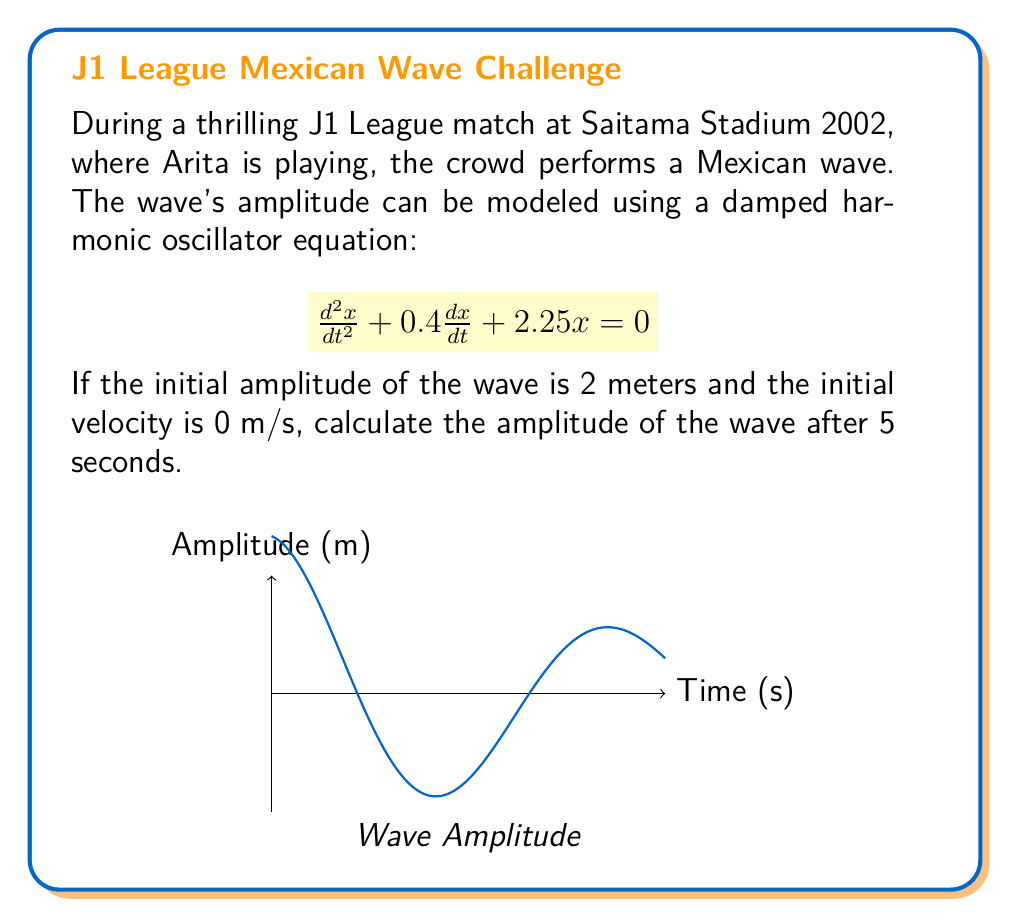Help me with this question. To solve this problem, we'll follow these steps:

1) The general solution for a damped harmonic oscillator is:
   $$x(t) = Ae^{-\gamma t}\cos(\omega t + \phi)$$
   where $A$ is the initial amplitude, $\gamma$ is the damping coefficient, $\omega$ is the angular frequency, and $\phi$ is the phase shift.

2) From the given equation, we can identify:
   $$\gamma = 0.2$$ (half of the coefficient of $\frac{dx}{dt}$)
   $$\omega^2 = 2.25 - \gamma^2 = 2.25 - 0.04 = 2.21$$
   $$\omega = \sqrt{2.21} \approx 1.49$$

3) Given initial conditions:
   $x(0) = 2$ (initial amplitude)
   $\frac{dx}{dt}(0) = 0$ (initial velocity)

4) The phase shift $\phi = 0$ because $\cos(0) = 1$, matching our initial amplitude.

5) Now we can write our specific solution:
   $$x(t) = 2e^{-0.2t}\cos(1.49t)$$

6) To find the amplitude after 5 seconds, we substitute $t = 5$:
   $$x(5) = 2e^{-0.2(5)}\cos(1.49(5))$$

7) Calculate:
   $$x(5) = 2e^{-1}\cos(7.45)$$
   $$x(5) \approx 2(0.368)(-0.875)$$
   $$x(5) \approx -0.644$$

The negative sign indicates the direction of the wave, but for amplitude, we take the absolute value.
Answer: $0.644$ meters 